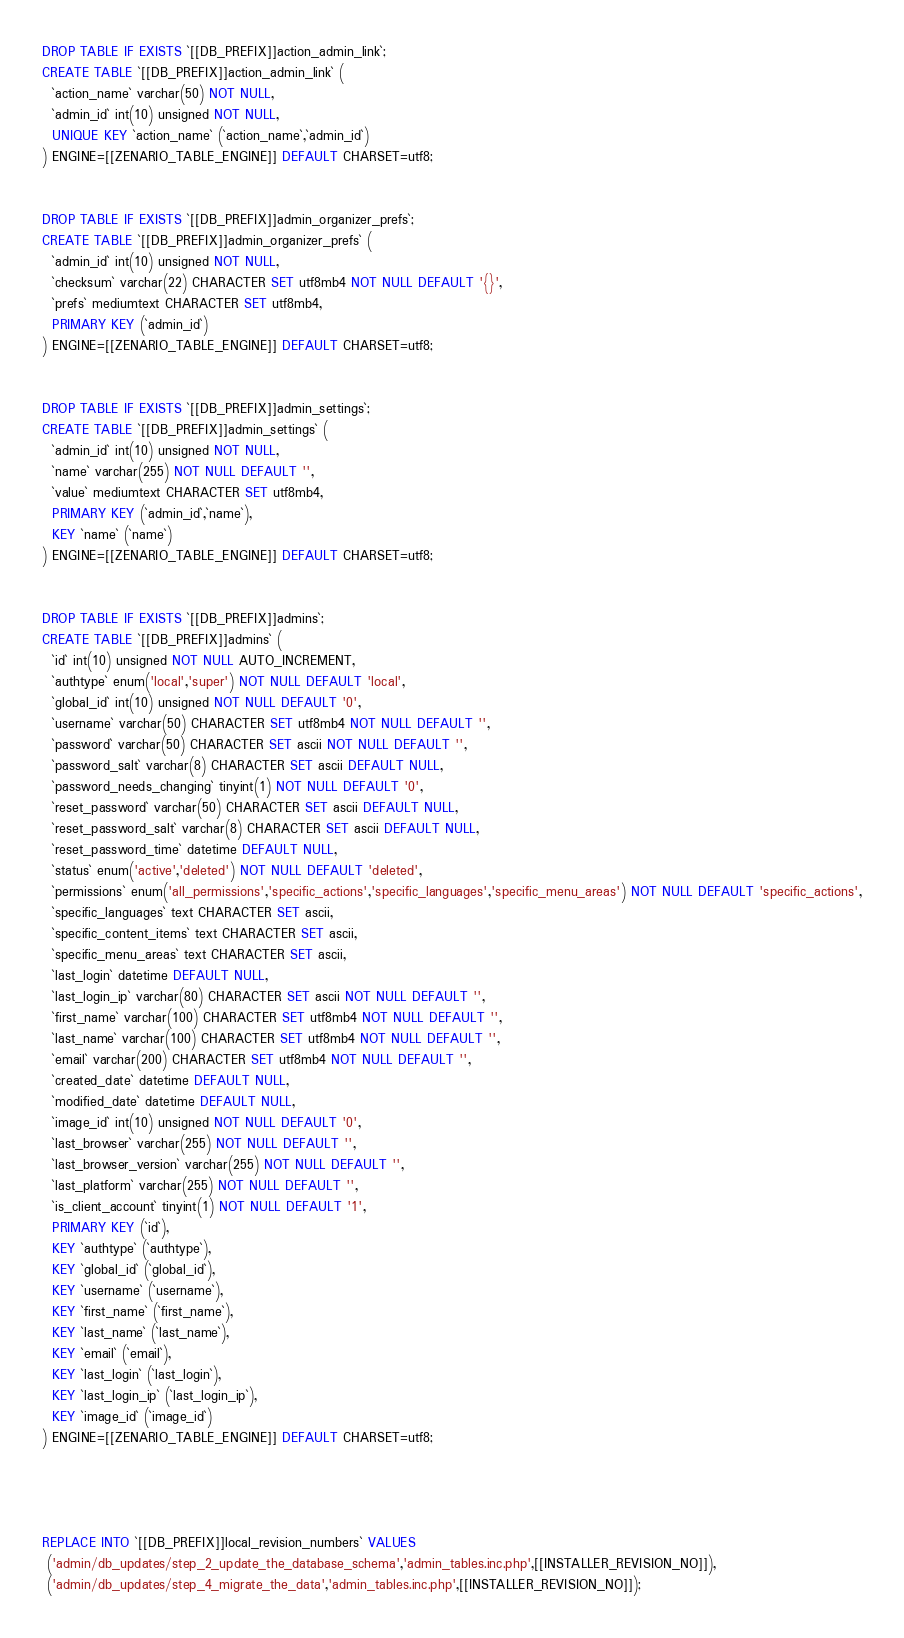Convert code to text. <code><loc_0><loc_0><loc_500><loc_500><_SQL_>


DROP TABLE IF EXISTS `[[DB_PREFIX]]action_admin_link`;
CREATE TABLE `[[DB_PREFIX]]action_admin_link` (
  `action_name` varchar(50) NOT NULL,
  `admin_id` int(10) unsigned NOT NULL,
  UNIQUE KEY `action_name` (`action_name`,`admin_id`)
) ENGINE=[[ZENARIO_TABLE_ENGINE]] DEFAULT CHARSET=utf8;


DROP TABLE IF EXISTS `[[DB_PREFIX]]admin_organizer_prefs`;
CREATE TABLE `[[DB_PREFIX]]admin_organizer_prefs` (
  `admin_id` int(10) unsigned NOT NULL,
  `checksum` varchar(22) CHARACTER SET utf8mb4 NOT NULL DEFAULT '{}',
  `prefs` mediumtext CHARACTER SET utf8mb4,
  PRIMARY KEY (`admin_id`)
) ENGINE=[[ZENARIO_TABLE_ENGINE]] DEFAULT CHARSET=utf8;


DROP TABLE IF EXISTS `[[DB_PREFIX]]admin_settings`;
CREATE TABLE `[[DB_PREFIX]]admin_settings` (
  `admin_id` int(10) unsigned NOT NULL,
  `name` varchar(255) NOT NULL DEFAULT '',
  `value` mediumtext CHARACTER SET utf8mb4,
  PRIMARY KEY (`admin_id`,`name`),
  KEY `name` (`name`)
) ENGINE=[[ZENARIO_TABLE_ENGINE]] DEFAULT CHARSET=utf8;


DROP TABLE IF EXISTS `[[DB_PREFIX]]admins`;
CREATE TABLE `[[DB_PREFIX]]admins` (
  `id` int(10) unsigned NOT NULL AUTO_INCREMENT,
  `authtype` enum('local','super') NOT NULL DEFAULT 'local',
  `global_id` int(10) unsigned NOT NULL DEFAULT '0',
  `username` varchar(50) CHARACTER SET utf8mb4 NOT NULL DEFAULT '',
  `password` varchar(50) CHARACTER SET ascii NOT NULL DEFAULT '',
  `password_salt` varchar(8) CHARACTER SET ascii DEFAULT NULL,
  `password_needs_changing` tinyint(1) NOT NULL DEFAULT '0',
  `reset_password` varchar(50) CHARACTER SET ascii DEFAULT NULL,
  `reset_password_salt` varchar(8) CHARACTER SET ascii DEFAULT NULL,
  `reset_password_time` datetime DEFAULT NULL,
  `status` enum('active','deleted') NOT NULL DEFAULT 'deleted',
  `permissions` enum('all_permissions','specific_actions','specific_languages','specific_menu_areas') NOT NULL DEFAULT 'specific_actions',
  `specific_languages` text CHARACTER SET ascii,
  `specific_content_items` text CHARACTER SET ascii,
  `specific_menu_areas` text CHARACTER SET ascii,
  `last_login` datetime DEFAULT NULL,
  `last_login_ip` varchar(80) CHARACTER SET ascii NOT NULL DEFAULT '',
  `first_name` varchar(100) CHARACTER SET utf8mb4 NOT NULL DEFAULT '',
  `last_name` varchar(100) CHARACTER SET utf8mb4 NOT NULL DEFAULT '',
  `email` varchar(200) CHARACTER SET utf8mb4 NOT NULL DEFAULT '',
  `created_date` datetime DEFAULT NULL,
  `modified_date` datetime DEFAULT NULL,
  `image_id` int(10) unsigned NOT NULL DEFAULT '0',
  `last_browser` varchar(255) NOT NULL DEFAULT '',
  `last_browser_version` varchar(255) NOT NULL DEFAULT '',
  `last_platform` varchar(255) NOT NULL DEFAULT '',
  `is_client_account` tinyint(1) NOT NULL DEFAULT '1',
  PRIMARY KEY (`id`),
  KEY `authtype` (`authtype`),
  KEY `global_id` (`global_id`),
  KEY `username` (`username`),
  KEY `first_name` (`first_name`),
  KEY `last_name` (`last_name`),
  KEY `email` (`email`),
  KEY `last_login` (`last_login`),
  KEY `last_login_ip` (`last_login_ip`),
  KEY `image_id` (`image_id`)
) ENGINE=[[ZENARIO_TABLE_ENGINE]] DEFAULT CHARSET=utf8;




REPLACE INTO `[[DB_PREFIX]]local_revision_numbers` VALUES
 ('admin/db_updates/step_2_update_the_database_schema','admin_tables.inc.php',[[INSTALLER_REVISION_NO]]),
 ('admin/db_updates/step_4_migrate_the_data','admin_tables.inc.php',[[INSTALLER_REVISION_NO]]);
</code> 